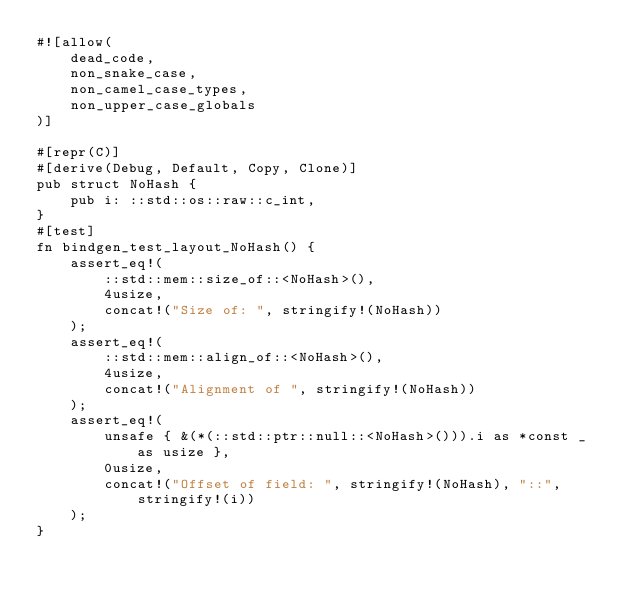<code> <loc_0><loc_0><loc_500><loc_500><_Rust_>#![allow(
    dead_code,
    non_snake_case,
    non_camel_case_types,
    non_upper_case_globals
)]

#[repr(C)]
#[derive(Debug, Default, Copy, Clone)]
pub struct NoHash {
    pub i: ::std::os::raw::c_int,
}
#[test]
fn bindgen_test_layout_NoHash() {
    assert_eq!(
        ::std::mem::size_of::<NoHash>(),
        4usize,
        concat!("Size of: ", stringify!(NoHash))
    );
    assert_eq!(
        ::std::mem::align_of::<NoHash>(),
        4usize,
        concat!("Alignment of ", stringify!(NoHash))
    );
    assert_eq!(
        unsafe { &(*(::std::ptr::null::<NoHash>())).i as *const _ as usize },
        0usize,
        concat!("Offset of field: ", stringify!(NoHash), "::", stringify!(i))
    );
}
</code> 